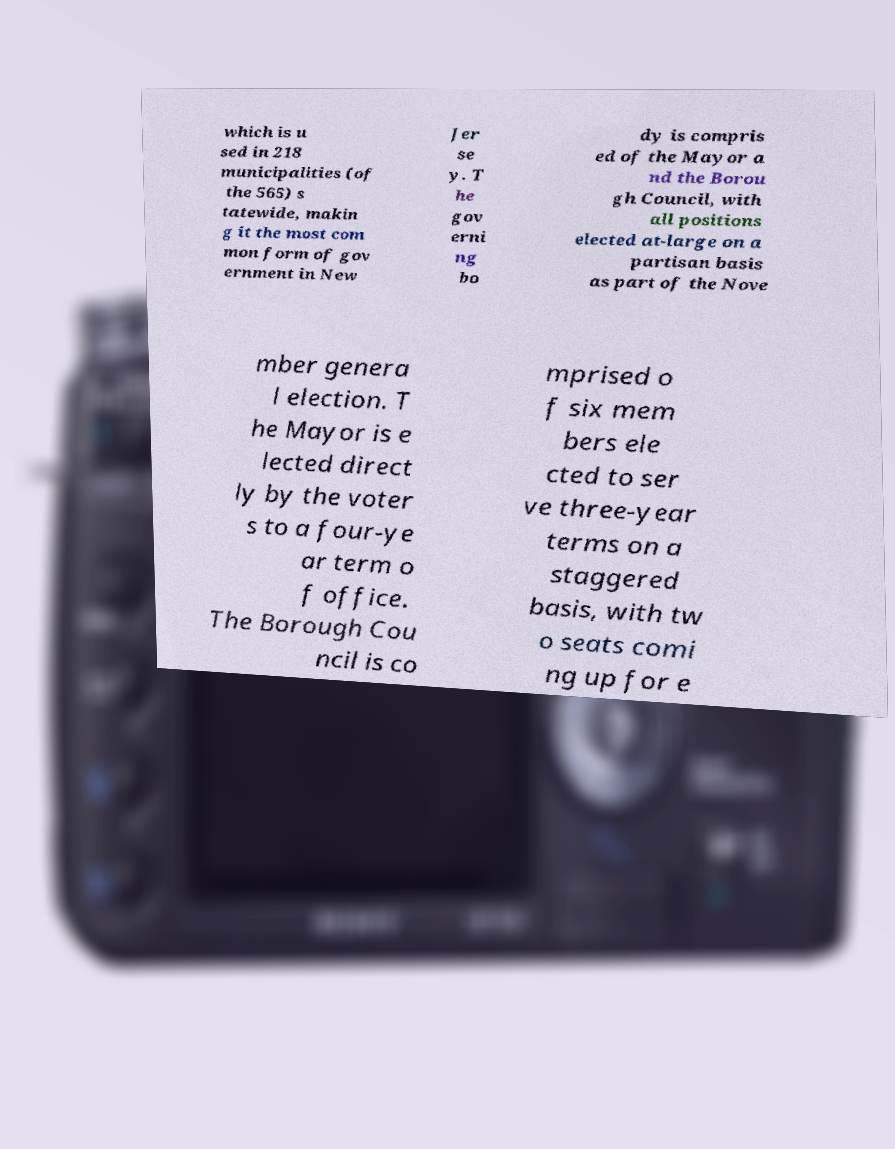Could you assist in decoding the text presented in this image and type it out clearly? which is u sed in 218 municipalities (of the 565) s tatewide, makin g it the most com mon form of gov ernment in New Jer se y. T he gov erni ng bo dy is compris ed of the Mayor a nd the Borou gh Council, with all positions elected at-large on a partisan basis as part of the Nove mber genera l election. T he Mayor is e lected direct ly by the voter s to a four-ye ar term o f office. The Borough Cou ncil is co mprised o f six mem bers ele cted to ser ve three-year terms on a staggered basis, with tw o seats comi ng up for e 